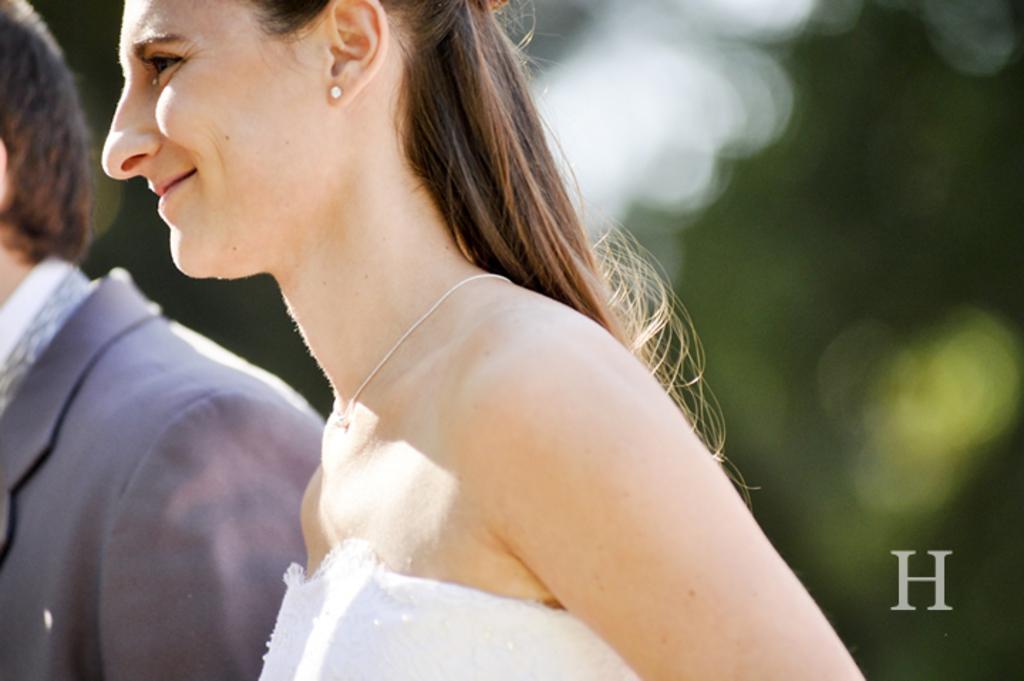Describe this image in one or two sentences. In this image we can see a woman and beside her there is a person. In the background the image is blur but we can see objects and on the right side there is a letter 'H' on the image. 